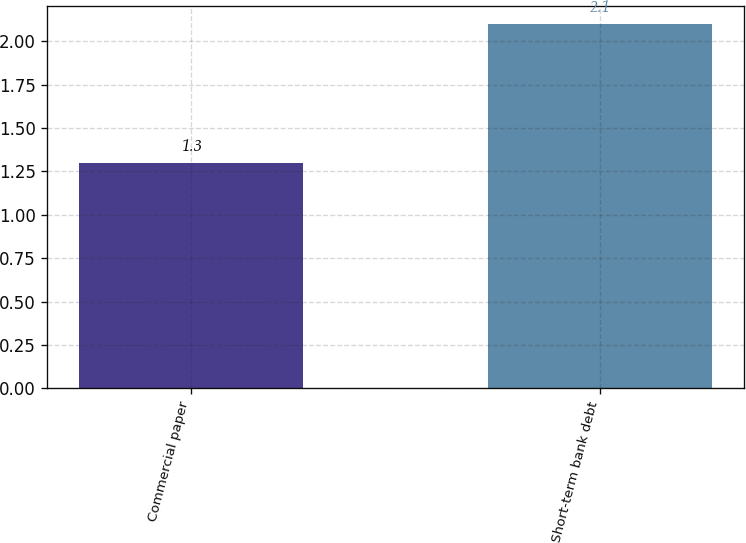<chart> <loc_0><loc_0><loc_500><loc_500><bar_chart><fcel>Commercial paper<fcel>Short-term bank debt<nl><fcel>1.3<fcel>2.1<nl></chart> 